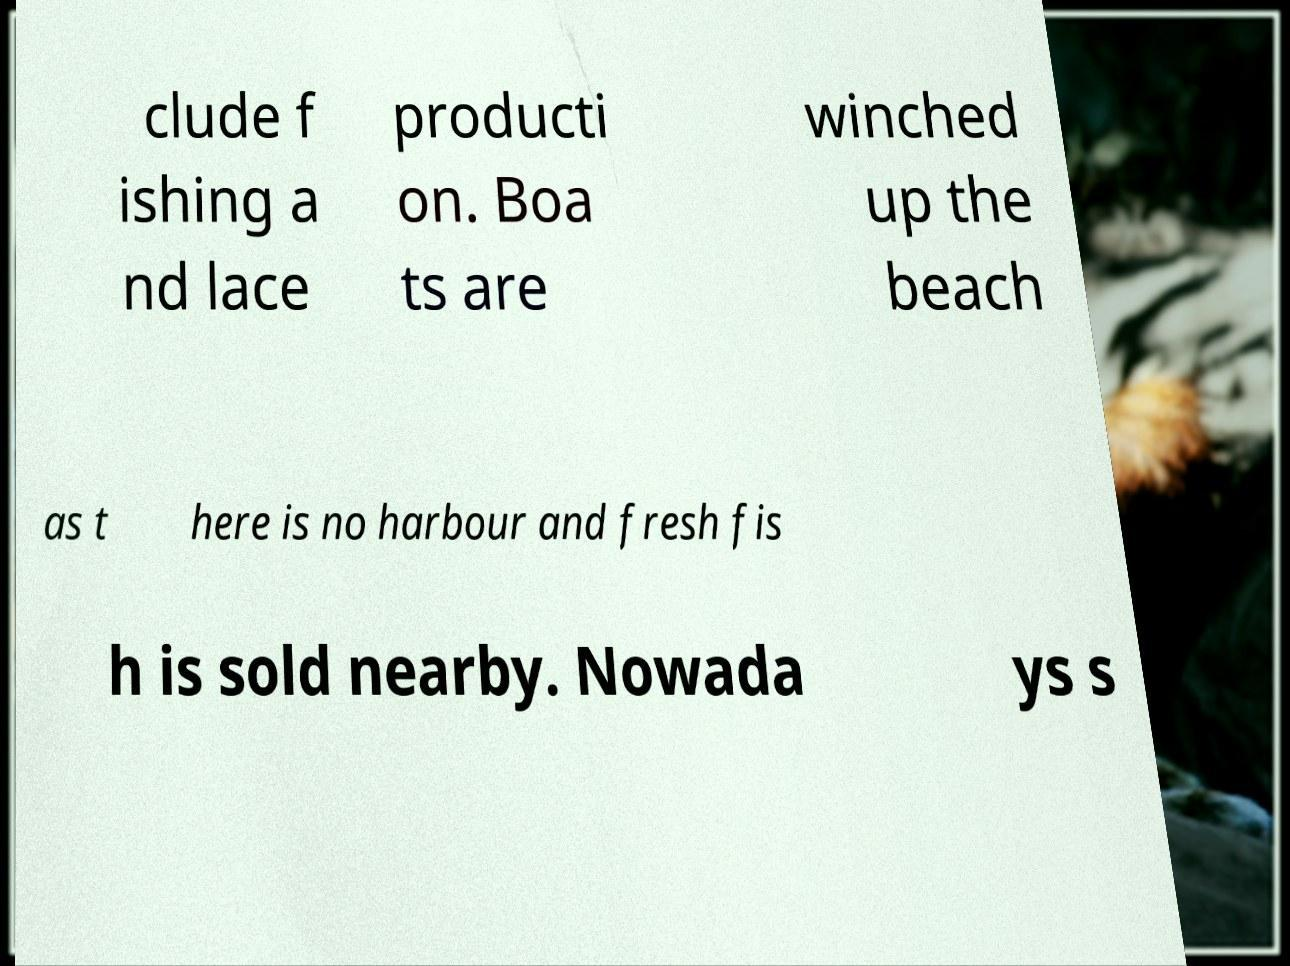Could you assist in decoding the text presented in this image and type it out clearly? clude f ishing a nd lace producti on. Boa ts are winched up the beach as t here is no harbour and fresh fis h is sold nearby. Nowada ys s 